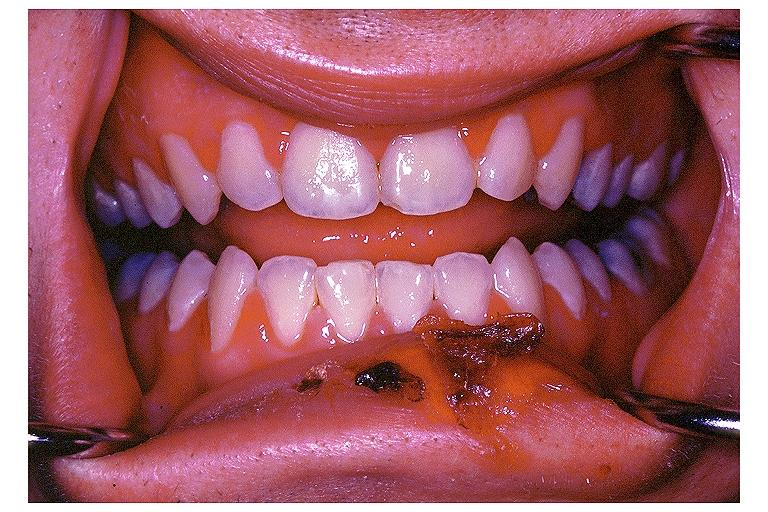does colon show primary herpetic gingivo-stomatitis?
Answer the question using a single word or phrase. No 